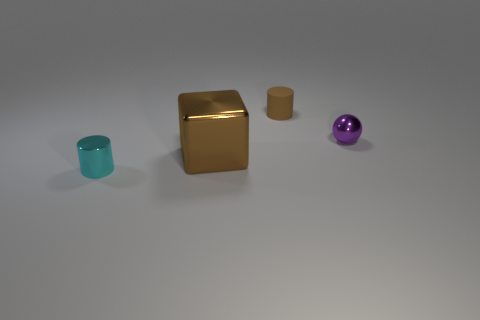What material is the object that is behind the small purple ball?
Your response must be concise. Rubber. There is a ball that is made of the same material as the large object; what color is it?
Your response must be concise. Purple. How many cyan metal cylinders have the same size as the brown matte cylinder?
Ensure brevity in your answer.  1. There is a cylinder that is to the left of the brown shiny thing; is its size the same as the large shiny object?
Provide a succinct answer. No. What shape is the object that is in front of the small brown rubber thing and to the right of the block?
Your response must be concise. Sphere. There is a brown rubber object; are there any big brown cubes left of it?
Give a very brief answer. Yes. Is there any other thing that is the same shape as the big thing?
Provide a short and direct response. No. Is the cyan metallic thing the same shape as the purple shiny thing?
Keep it short and to the point. No. Are there the same number of small brown rubber objects behind the tiny brown matte thing and large brown metal cubes that are right of the brown metallic cube?
Your response must be concise. Yes. How many other things are the same material as the brown cylinder?
Your response must be concise. 0. 